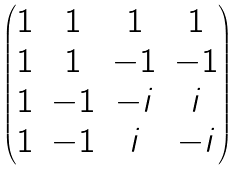Convert formula to latex. <formula><loc_0><loc_0><loc_500><loc_500>\begin{pmatrix} 1 & 1 & 1 & 1 \\ 1 & 1 & - 1 & - 1 \\ 1 & - 1 & - i & i \\ 1 & - 1 & i & - i \end{pmatrix}</formula> 